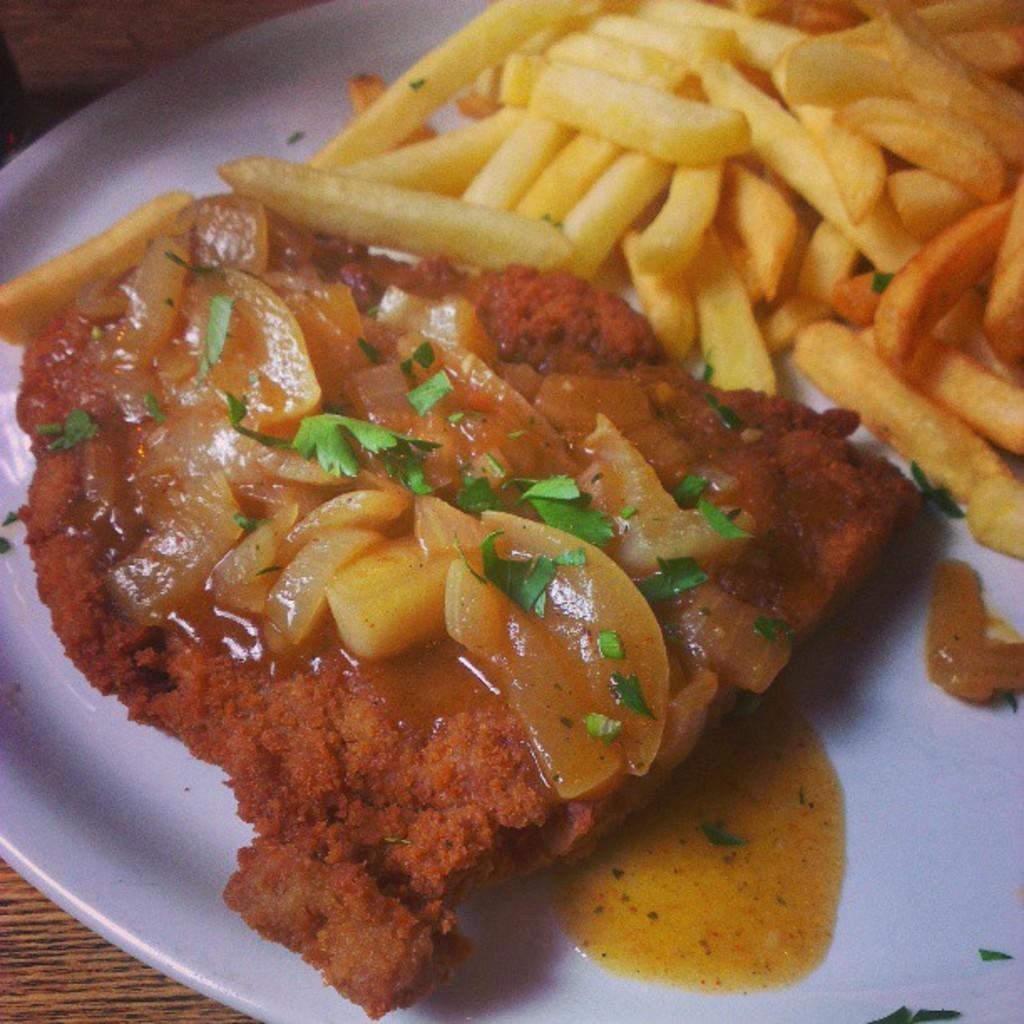Could you give a brief overview of what you see in this image? In this image, I can see a plate, which contains french fries, chopped onions, coriander leaves and a food item on the plate. I think this is the wooden table. 